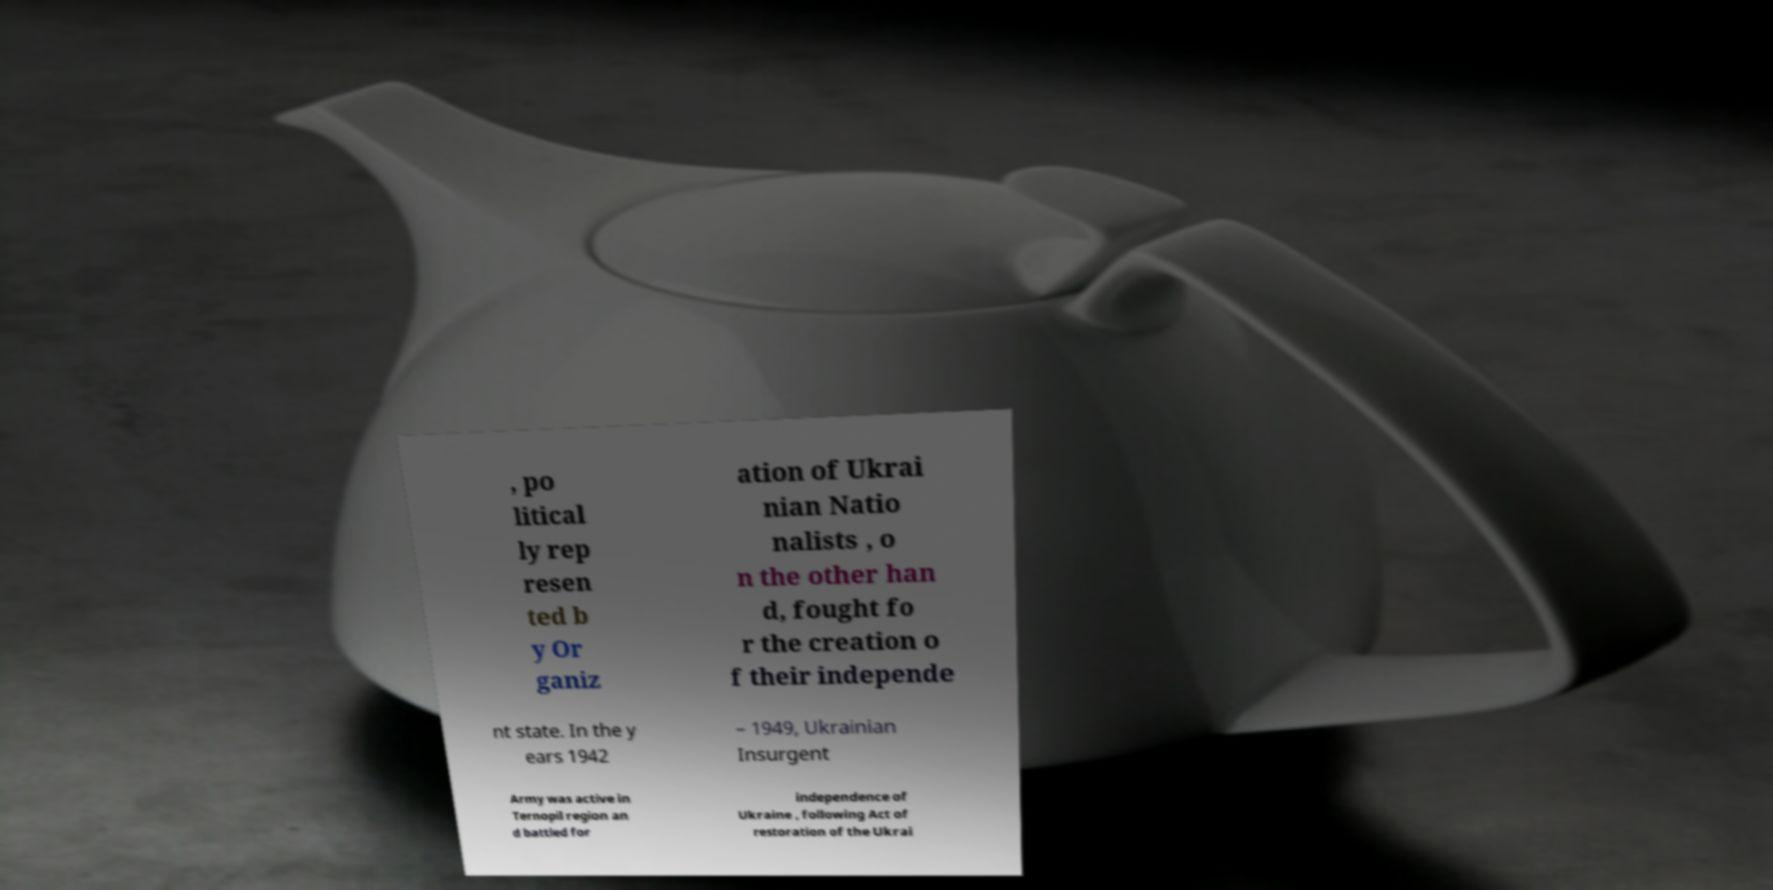Could you extract and type out the text from this image? , po litical ly rep resen ted b y Or ganiz ation of Ukrai nian Natio nalists , o n the other han d, fought fo r the creation o f their independe nt state. In the y ears 1942 – 1949, Ukrainian Insurgent Army was active in Ternopil region an d battled for independence of Ukraine , following Act of restoration of the Ukrai 